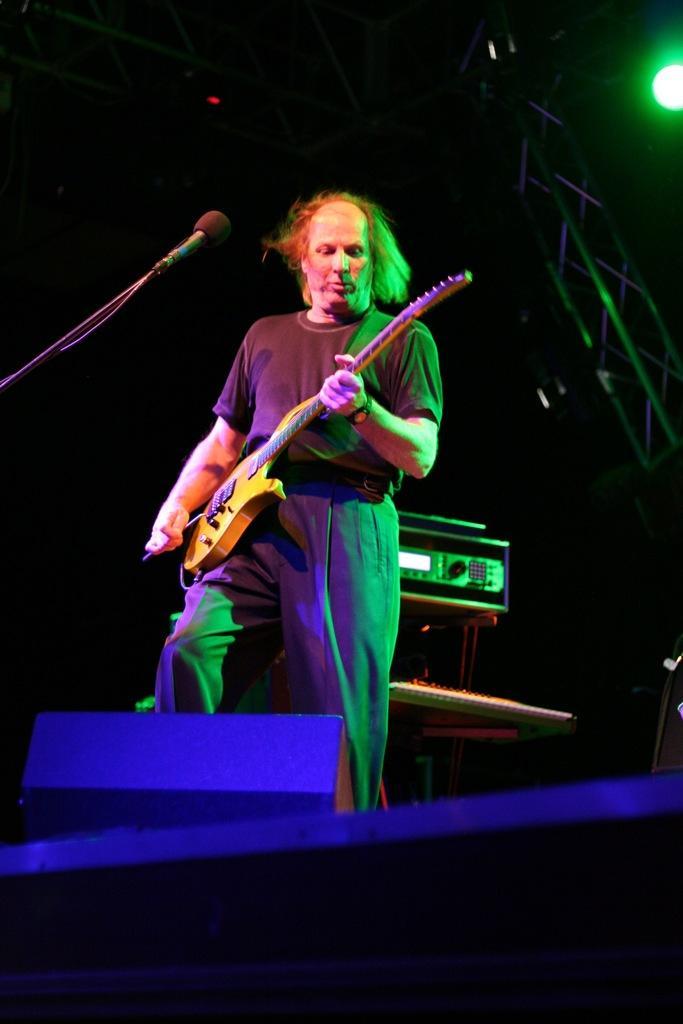Describe this image in one or two sentences. This is the picture of a guy in black dress is holding a guitar and playing it in front of the mic and behind there is a musical instrument and a speaker. 